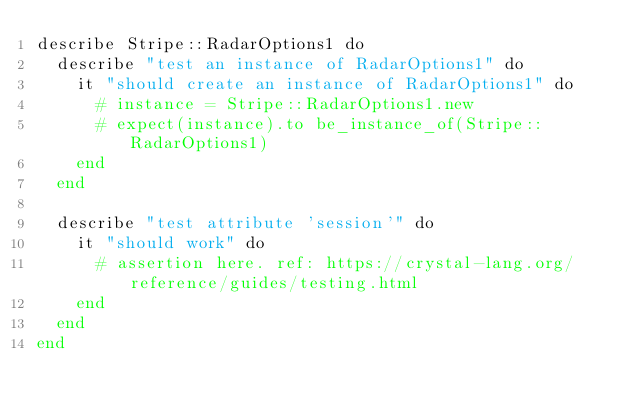<code> <loc_0><loc_0><loc_500><loc_500><_Crystal_>describe Stripe::RadarOptions1 do
  describe "test an instance of RadarOptions1" do
    it "should create an instance of RadarOptions1" do
      # instance = Stripe::RadarOptions1.new
      # expect(instance).to be_instance_of(Stripe::RadarOptions1)
    end
  end

  describe "test attribute 'session'" do
    it "should work" do
      # assertion here. ref: https://crystal-lang.org/reference/guides/testing.html
    end
  end
end
</code> 